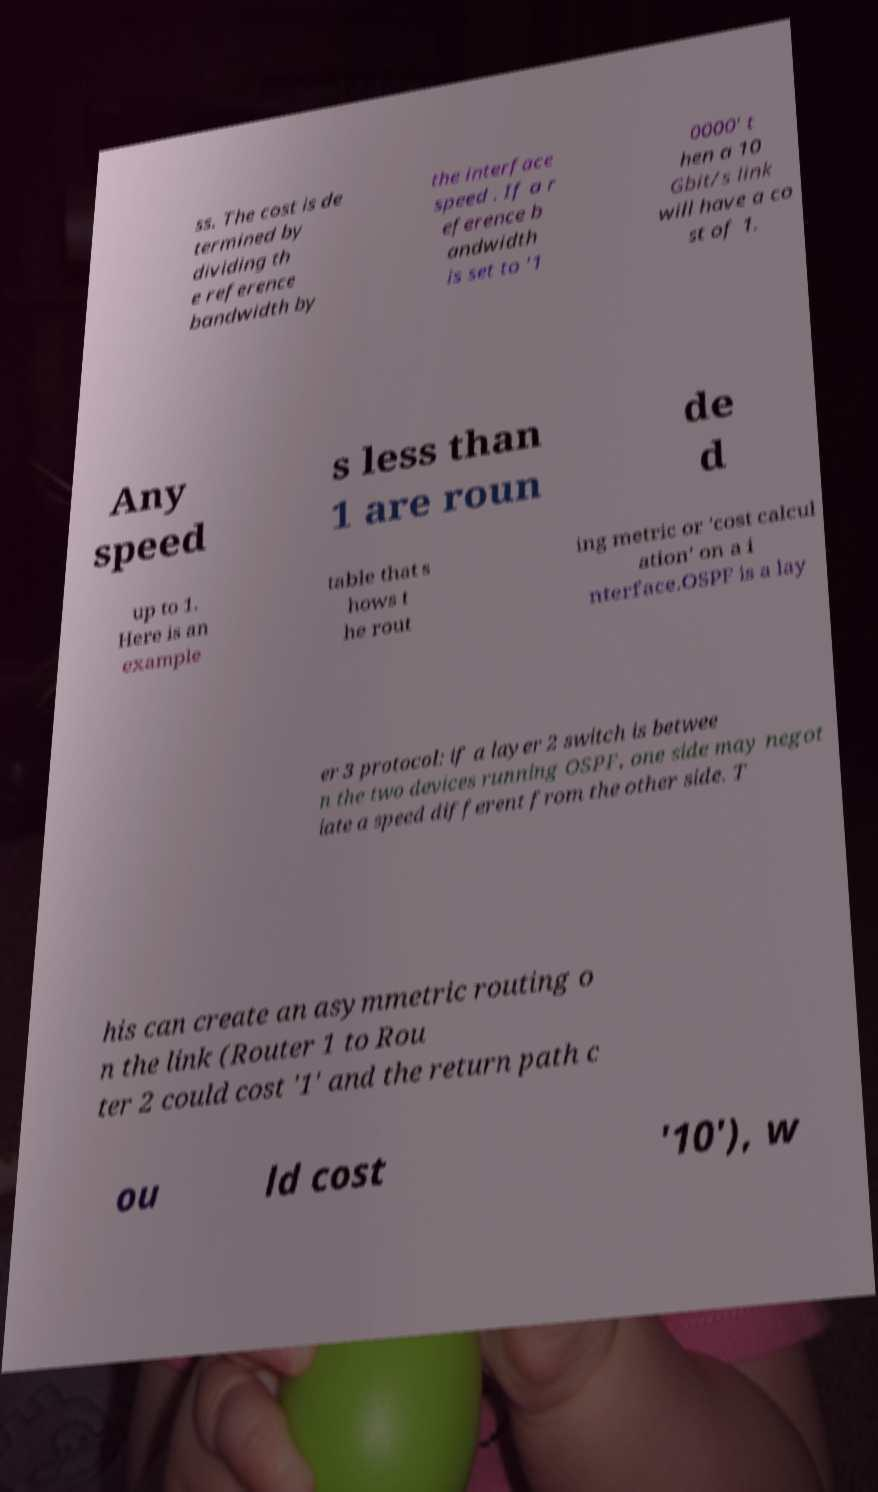Please read and relay the text visible in this image. What does it say? ss. The cost is de termined by dividing th e reference bandwidth by the interface speed . If a r eference b andwidth is set to '1 0000' t hen a 10 Gbit/s link will have a co st of 1. Any speed s less than 1 are roun de d up to 1. Here is an example table that s hows t he rout ing metric or 'cost calcul ation' on a i nterface.OSPF is a lay er 3 protocol: if a layer 2 switch is betwee n the two devices running OSPF, one side may negot iate a speed different from the other side. T his can create an asymmetric routing o n the link (Router 1 to Rou ter 2 could cost '1' and the return path c ou ld cost '10'), w 